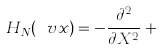<formula> <loc_0><loc_0><loc_500><loc_500>H _ { N } ( \ v x ) = - \frac { \partial ^ { 2 } } { \partial X ^ { 2 } } + \cdots</formula> 